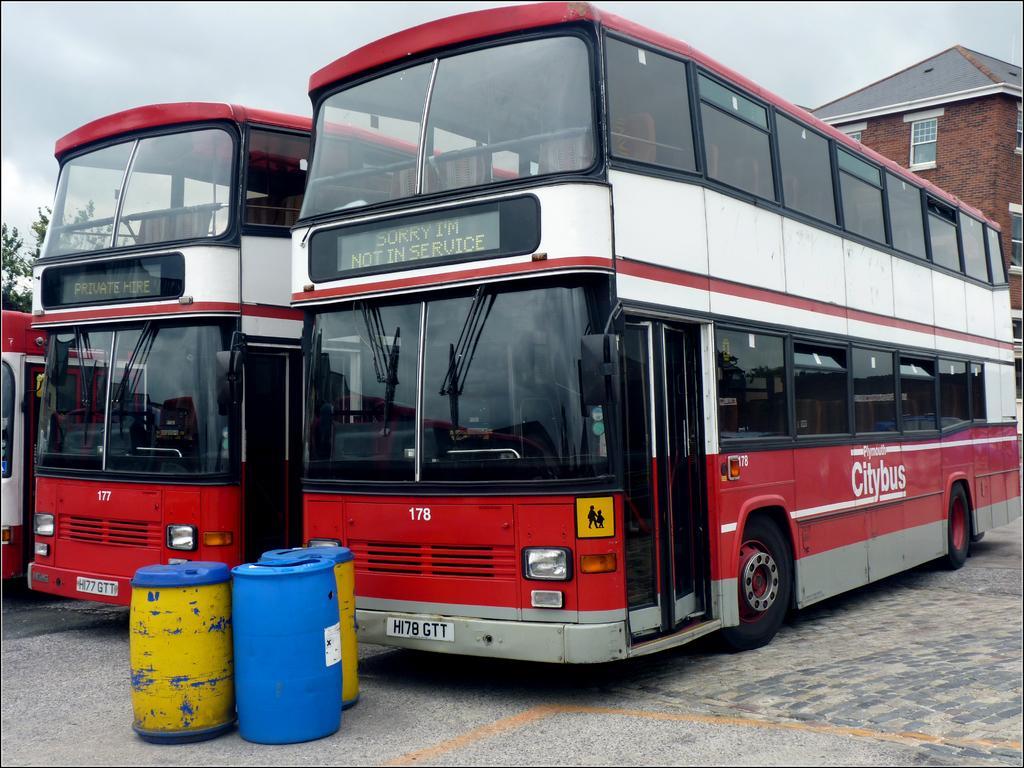Please provide a concise description of this image. In this image, I can see two double-decker buses, which are red and white in color. There are three barrels on the road. This is the building with windows. At the left corner of the image, that looks like a tree. This is the sky. 